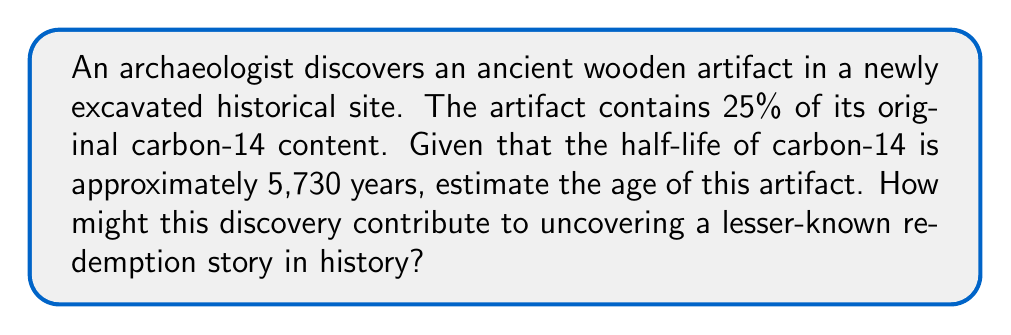What is the answer to this math problem? To solve this problem, we'll use the radioactive decay formula and the given information:

1. Let $N(t)$ be the amount of carbon-14 at time $t$, and $N_0$ be the initial amount.
2. The decay formula is: $N(t) = N_0 \cdot 2^{-t/t_{1/2}}$
   Where $t_{1/2}$ is the half-life.

3. We know that $N(t) = 0.25N_0$ (25% of original content)
   and $t_{1/2} = 5730$ years

4. Substituting into the decay formula:
   $0.25N_0 = N_0 \cdot 2^{-t/5730}$

5. Simplify:
   $0.25 = 2^{-t/5730}$

6. Take the natural log of both sides:
   $\ln(0.25) = \ln(2^{-t/5730})$

7. Simplify the right side:
   $\ln(0.25) = -\frac{t}{5730} \cdot \ln(2)$

8. Solve for $t$:
   $t = -5730 \cdot \frac{\ln(0.25)}{\ln(2)} \approx 11,460$ years

This age estimation could contribute to uncovering a lesser-known redemption story by providing a precise timeline for the artifact, potentially linking it to a specific historical period or event that may have been overlooked in traditional narratives.
Answer: 11,460 years 